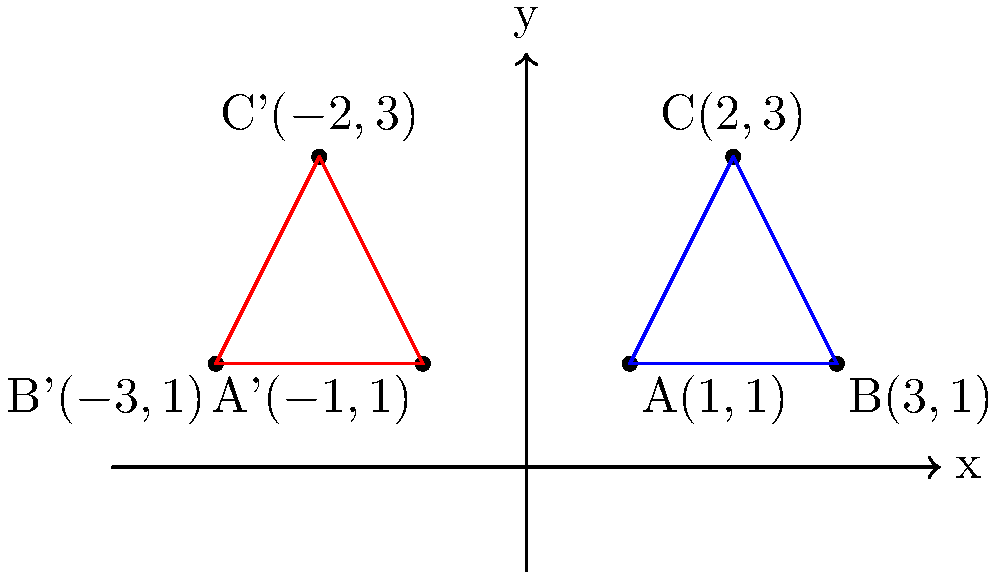A triangle ABC with vertices A(1,1), B(3,1), and C(2,3) is reflected across the y-axis to form triangle A'B'C'. What transformation would map triangle A'B'C' back onto triangle ABC? To solve this problem, let's follow these steps:

1) First, observe that triangle A'B'C' is a reflection of triangle ABC across the y-axis.

2) The reflection across the y-axis changes the sign of the x-coordinates while keeping the y-coordinates the same. This is why:
   A(1,1) becomes A'(-1,1)
   B(3,1) becomes B'(-3,1)
   C(2,3) becomes C'(-2,3)

3) To map triangle A'B'C' back onto triangle ABC, we need to perform the inverse transformation of reflection across the y-axis.

4) The inverse of a reflection is the same reflection. In other words, reflecting A'B'C' across the y-axis will map it back onto ABC.

5) Mathematically, this can be represented as the transformation (x, y) → (-x, y) for each point of triangle A'B'C'.

Therefore, a reflection across the y-axis would map triangle A'B'C' back onto triangle ABC.
Answer: Reflection across the y-axis 